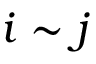<formula> <loc_0><loc_0><loc_500><loc_500>i \sim j</formula> 